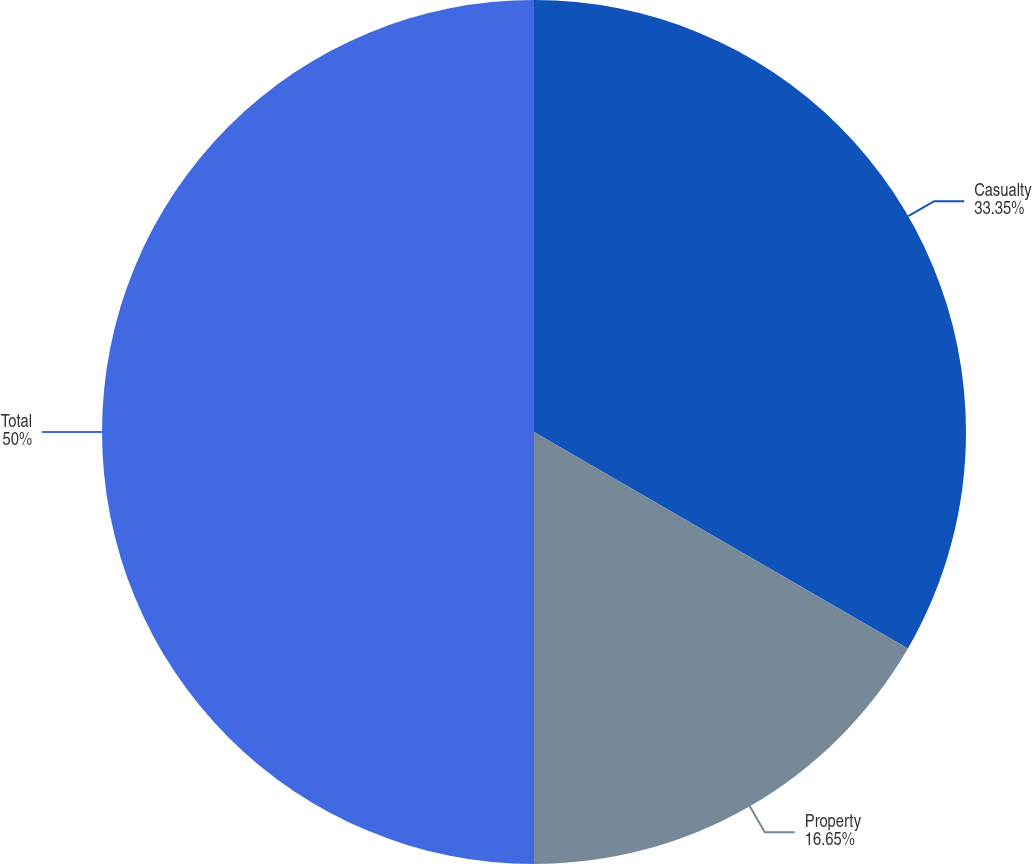Convert chart. <chart><loc_0><loc_0><loc_500><loc_500><pie_chart><fcel>Casualty<fcel>Property<fcel>Total<nl><fcel>33.35%<fcel>16.65%<fcel>50.0%<nl></chart> 